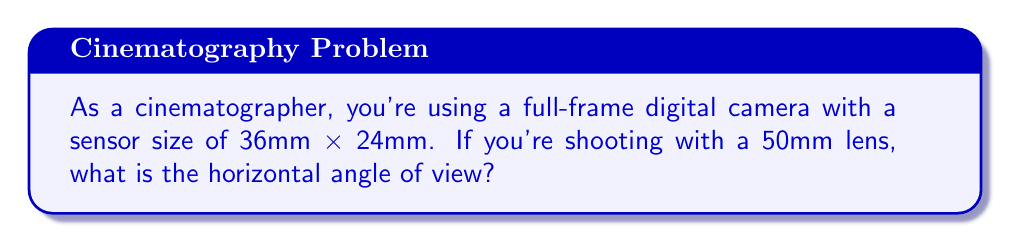Provide a solution to this math problem. To solve this problem, we need to use the formula for calculating the angle of view given the focal length and sensor size. The formula for the horizontal angle of view is:

$$ \text{AOV} = 2 \arctan\left(\frac{d}{2f}\right) $$

Where:
- AOV is the angle of view in radians
- d is the width of the sensor
- f is the focal length of the lens

Given:
- Sensor width (d) = 36mm
- Focal length (f) = 50mm

Let's substitute these values into our formula:

$$ \text{AOV} = 2 \arctan\left(\frac{36}{2 \times 50}\right) $$

$$ \text{AOV} = 2 \arctan\left(\frac{18}{50}\right) $$

$$ \text{AOV} = 2 \arctan(0.36) $$

Now, let's calculate this:

$$ \text{AOV} = 2 \times 0.3479 \text{ radians} $$

$$ \text{AOV} = 0.6958 \text{ radians} $$

To convert this to degrees, we multiply by $\frac{180}{\pi}$:

$$ \text{AOV} = 0.6958 \times \frac{180}{\pi} \approx 39.6^\circ $$

Therefore, the horizontal angle of view is approximately 39.6°.
Answer: $39.6^\circ$ 